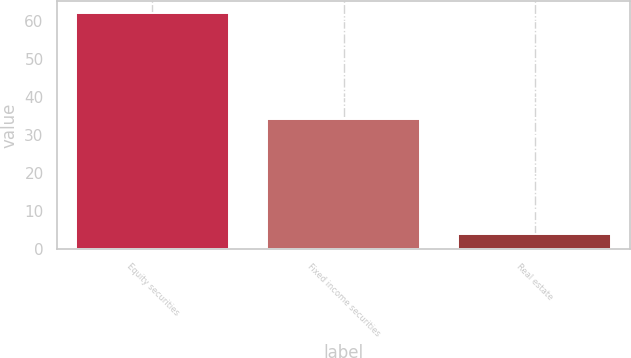Convert chart to OTSL. <chart><loc_0><loc_0><loc_500><loc_500><bar_chart><fcel>Equity securities<fcel>Fixed income securities<fcel>Real estate<nl><fcel>62<fcel>34<fcel>4<nl></chart> 